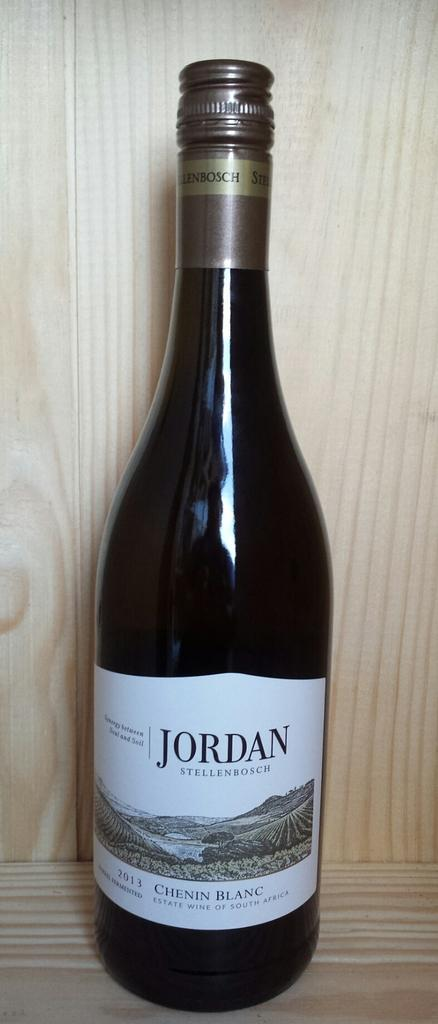<image>
Describe the image concisely. a bottle of Jordan Stellenbosch Chenin Blanc wine from South Africa 